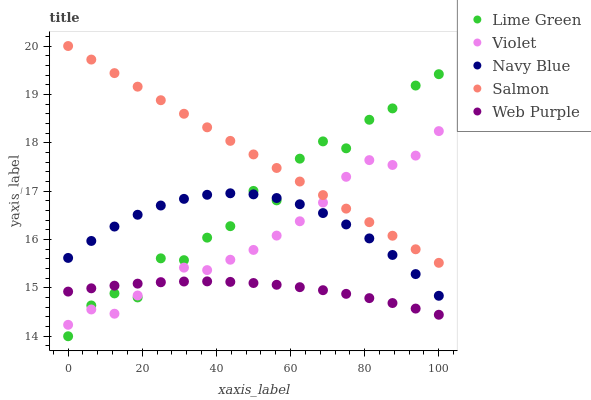Does Web Purple have the minimum area under the curve?
Answer yes or no. Yes. Does Salmon have the maximum area under the curve?
Answer yes or no. Yes. Does Salmon have the minimum area under the curve?
Answer yes or no. No. Does Web Purple have the maximum area under the curve?
Answer yes or no. No. Is Salmon the smoothest?
Answer yes or no. Yes. Is Lime Green the roughest?
Answer yes or no. Yes. Is Web Purple the smoothest?
Answer yes or no. No. Is Web Purple the roughest?
Answer yes or no. No. Does Lime Green have the lowest value?
Answer yes or no. Yes. Does Web Purple have the lowest value?
Answer yes or no. No. Does Salmon have the highest value?
Answer yes or no. Yes. Does Web Purple have the highest value?
Answer yes or no. No. Is Web Purple less than Salmon?
Answer yes or no. Yes. Is Salmon greater than Web Purple?
Answer yes or no. Yes. Does Lime Green intersect Navy Blue?
Answer yes or no. Yes. Is Lime Green less than Navy Blue?
Answer yes or no. No. Is Lime Green greater than Navy Blue?
Answer yes or no. No. Does Web Purple intersect Salmon?
Answer yes or no. No. 